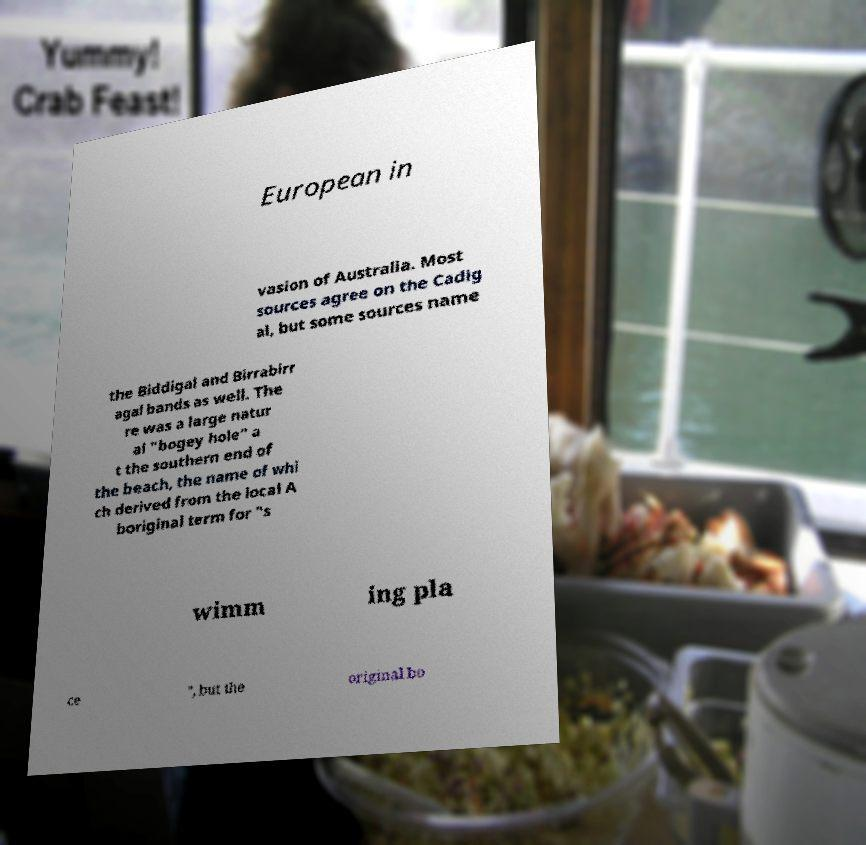Could you assist in decoding the text presented in this image and type it out clearly? European in vasion of Australia. Most sources agree on the Cadig al, but some sources name the Biddigal and Birrabirr agal bands as well. The re was a large natur al "bogey hole" a t the southern end of the beach, the name of whi ch derived from the local A boriginal term for "s wimm ing pla ce ", but the original bo 